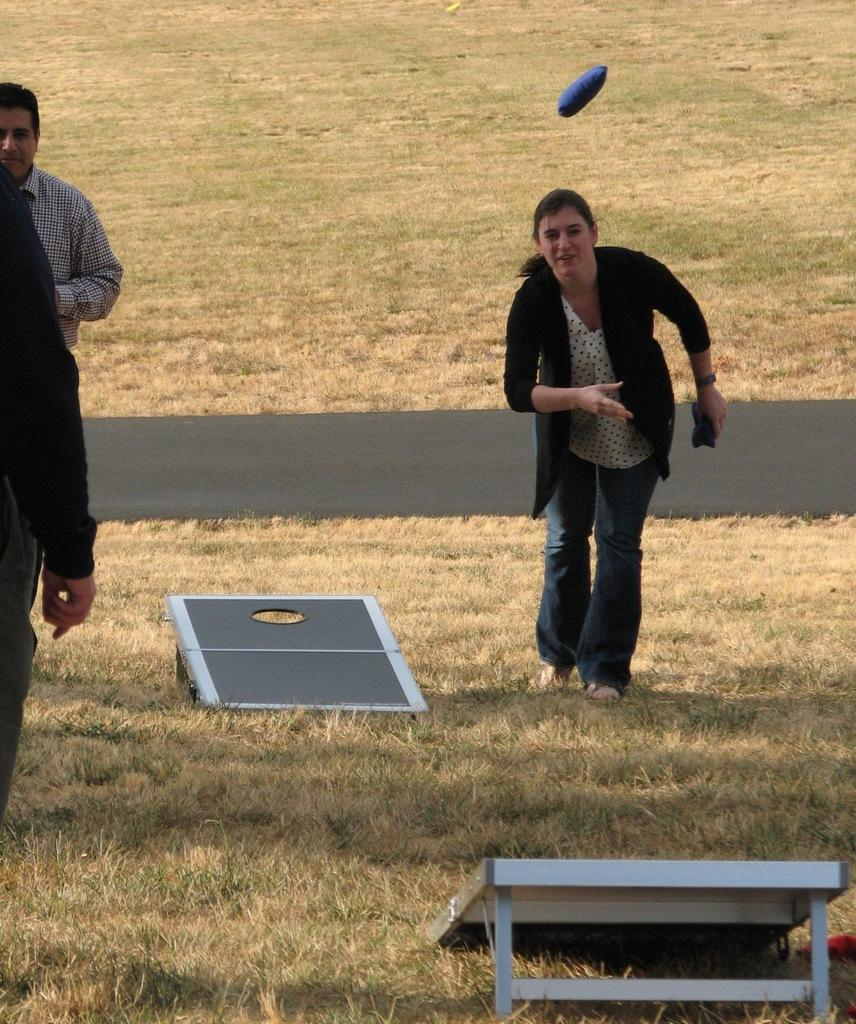What is the condition of the land in the image? The land is covered with dried grass. What can be seen on the dried grass? There are objects on the dried grass. How many people are in the image? There are three people in the image. What is the object in the air? Unfortunately, the provided facts do not give enough information to determine what the object in the air is. What type of finger can be seen pointing at the objects on the dried grass? There is no finger visible in the image; it only shows objects on the dried grass and three people. 